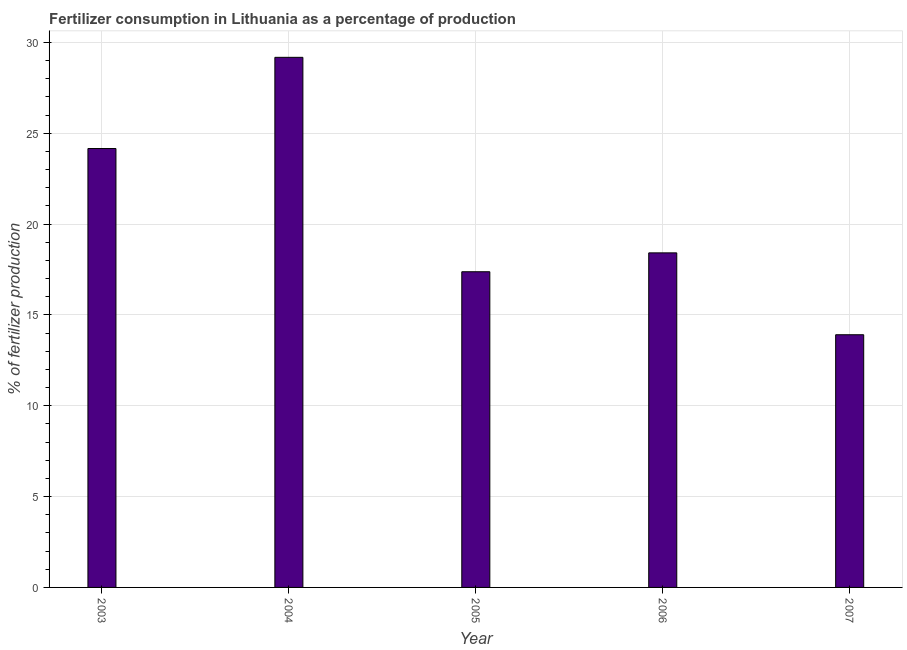Does the graph contain any zero values?
Make the answer very short. No. What is the title of the graph?
Keep it short and to the point. Fertilizer consumption in Lithuania as a percentage of production. What is the label or title of the Y-axis?
Offer a very short reply. % of fertilizer production. What is the amount of fertilizer consumption in 2005?
Ensure brevity in your answer.  17.38. Across all years, what is the maximum amount of fertilizer consumption?
Offer a terse response. 29.18. Across all years, what is the minimum amount of fertilizer consumption?
Your answer should be very brief. 13.91. What is the sum of the amount of fertilizer consumption?
Offer a terse response. 103.05. What is the difference between the amount of fertilizer consumption in 2005 and 2007?
Your response must be concise. 3.47. What is the average amount of fertilizer consumption per year?
Your answer should be very brief. 20.61. What is the median amount of fertilizer consumption?
Provide a succinct answer. 18.42. What is the ratio of the amount of fertilizer consumption in 2004 to that in 2007?
Your answer should be very brief. 2.1. Is the difference between the amount of fertilizer consumption in 2003 and 2005 greater than the difference between any two years?
Offer a terse response. No. What is the difference between the highest and the second highest amount of fertilizer consumption?
Provide a succinct answer. 5.02. What is the difference between the highest and the lowest amount of fertilizer consumption?
Your response must be concise. 15.27. In how many years, is the amount of fertilizer consumption greater than the average amount of fertilizer consumption taken over all years?
Ensure brevity in your answer.  2. How many years are there in the graph?
Your answer should be compact. 5. What is the difference between two consecutive major ticks on the Y-axis?
Offer a terse response. 5. What is the % of fertilizer production in 2003?
Offer a very short reply. 24.16. What is the % of fertilizer production of 2004?
Offer a terse response. 29.18. What is the % of fertilizer production of 2005?
Make the answer very short. 17.38. What is the % of fertilizer production in 2006?
Offer a terse response. 18.42. What is the % of fertilizer production in 2007?
Offer a very short reply. 13.91. What is the difference between the % of fertilizer production in 2003 and 2004?
Your response must be concise. -5.02. What is the difference between the % of fertilizer production in 2003 and 2005?
Your response must be concise. 6.78. What is the difference between the % of fertilizer production in 2003 and 2006?
Offer a very short reply. 5.74. What is the difference between the % of fertilizer production in 2003 and 2007?
Your answer should be compact. 10.25. What is the difference between the % of fertilizer production in 2004 and 2005?
Ensure brevity in your answer.  11.8. What is the difference between the % of fertilizer production in 2004 and 2006?
Your answer should be compact. 10.76. What is the difference between the % of fertilizer production in 2004 and 2007?
Give a very brief answer. 15.27. What is the difference between the % of fertilizer production in 2005 and 2006?
Keep it short and to the point. -1.04. What is the difference between the % of fertilizer production in 2005 and 2007?
Offer a terse response. 3.47. What is the difference between the % of fertilizer production in 2006 and 2007?
Make the answer very short. 4.51. What is the ratio of the % of fertilizer production in 2003 to that in 2004?
Provide a short and direct response. 0.83. What is the ratio of the % of fertilizer production in 2003 to that in 2005?
Keep it short and to the point. 1.39. What is the ratio of the % of fertilizer production in 2003 to that in 2006?
Make the answer very short. 1.31. What is the ratio of the % of fertilizer production in 2003 to that in 2007?
Your answer should be compact. 1.74. What is the ratio of the % of fertilizer production in 2004 to that in 2005?
Give a very brief answer. 1.68. What is the ratio of the % of fertilizer production in 2004 to that in 2006?
Your response must be concise. 1.58. What is the ratio of the % of fertilizer production in 2004 to that in 2007?
Your answer should be compact. 2.1. What is the ratio of the % of fertilizer production in 2005 to that in 2006?
Make the answer very short. 0.94. What is the ratio of the % of fertilizer production in 2005 to that in 2007?
Give a very brief answer. 1.25. What is the ratio of the % of fertilizer production in 2006 to that in 2007?
Make the answer very short. 1.32. 